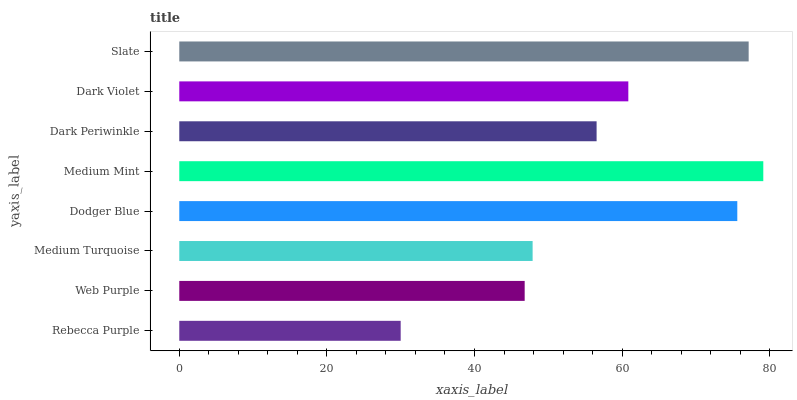Is Rebecca Purple the minimum?
Answer yes or no. Yes. Is Medium Mint the maximum?
Answer yes or no. Yes. Is Web Purple the minimum?
Answer yes or no. No. Is Web Purple the maximum?
Answer yes or no. No. Is Web Purple greater than Rebecca Purple?
Answer yes or no. Yes. Is Rebecca Purple less than Web Purple?
Answer yes or no. Yes. Is Rebecca Purple greater than Web Purple?
Answer yes or no. No. Is Web Purple less than Rebecca Purple?
Answer yes or no. No. Is Dark Violet the high median?
Answer yes or no. Yes. Is Dark Periwinkle the low median?
Answer yes or no. Yes. Is Slate the high median?
Answer yes or no. No. Is Rebecca Purple the low median?
Answer yes or no. No. 